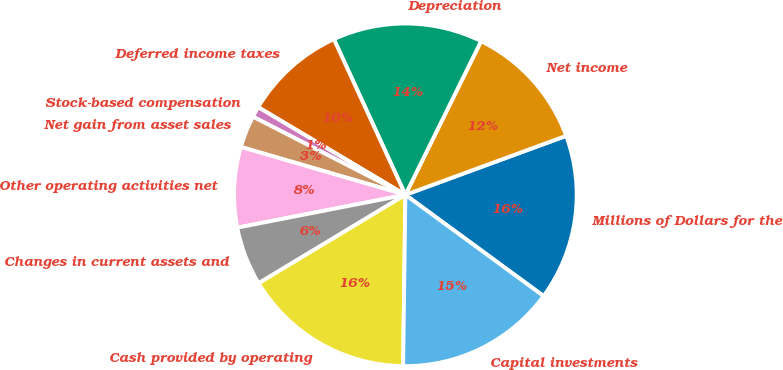<chart> <loc_0><loc_0><loc_500><loc_500><pie_chart><fcel>Millions of Dollars for the<fcel>Net income<fcel>Depreciation<fcel>Deferred income taxes<fcel>Stock-based compensation<fcel>Net gain from asset sales<fcel>Other operating activities net<fcel>Changes in current assets and<fcel>Cash provided by operating<fcel>Capital investments<nl><fcel>15.66%<fcel>12.12%<fcel>14.14%<fcel>9.6%<fcel>1.01%<fcel>3.03%<fcel>7.58%<fcel>5.56%<fcel>16.16%<fcel>15.15%<nl></chart> 